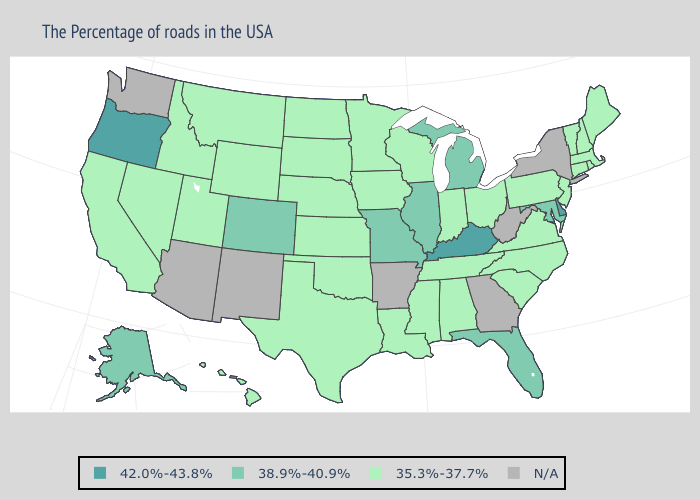What is the value of Ohio?
Keep it brief. 35.3%-37.7%. Name the states that have a value in the range 42.0%-43.8%?
Keep it brief. Delaware, Kentucky, Oregon. What is the highest value in the West ?
Short answer required. 42.0%-43.8%. Does Alaska have the lowest value in the USA?
Be succinct. No. What is the value of Oregon?
Give a very brief answer. 42.0%-43.8%. Which states have the highest value in the USA?
Be succinct. Delaware, Kentucky, Oregon. How many symbols are there in the legend?
Give a very brief answer. 4. What is the value of Massachusetts?
Keep it brief. 35.3%-37.7%. Name the states that have a value in the range 42.0%-43.8%?
Write a very short answer. Delaware, Kentucky, Oregon. What is the value of Pennsylvania?
Quick response, please. 35.3%-37.7%. Name the states that have a value in the range 35.3%-37.7%?
Give a very brief answer. Maine, Massachusetts, Rhode Island, New Hampshire, Vermont, Connecticut, New Jersey, Pennsylvania, Virginia, North Carolina, South Carolina, Ohio, Indiana, Alabama, Tennessee, Wisconsin, Mississippi, Louisiana, Minnesota, Iowa, Kansas, Nebraska, Oklahoma, Texas, South Dakota, North Dakota, Wyoming, Utah, Montana, Idaho, Nevada, California, Hawaii. Name the states that have a value in the range 42.0%-43.8%?
Keep it brief. Delaware, Kentucky, Oregon. What is the highest value in the South ?
Answer briefly. 42.0%-43.8%. 